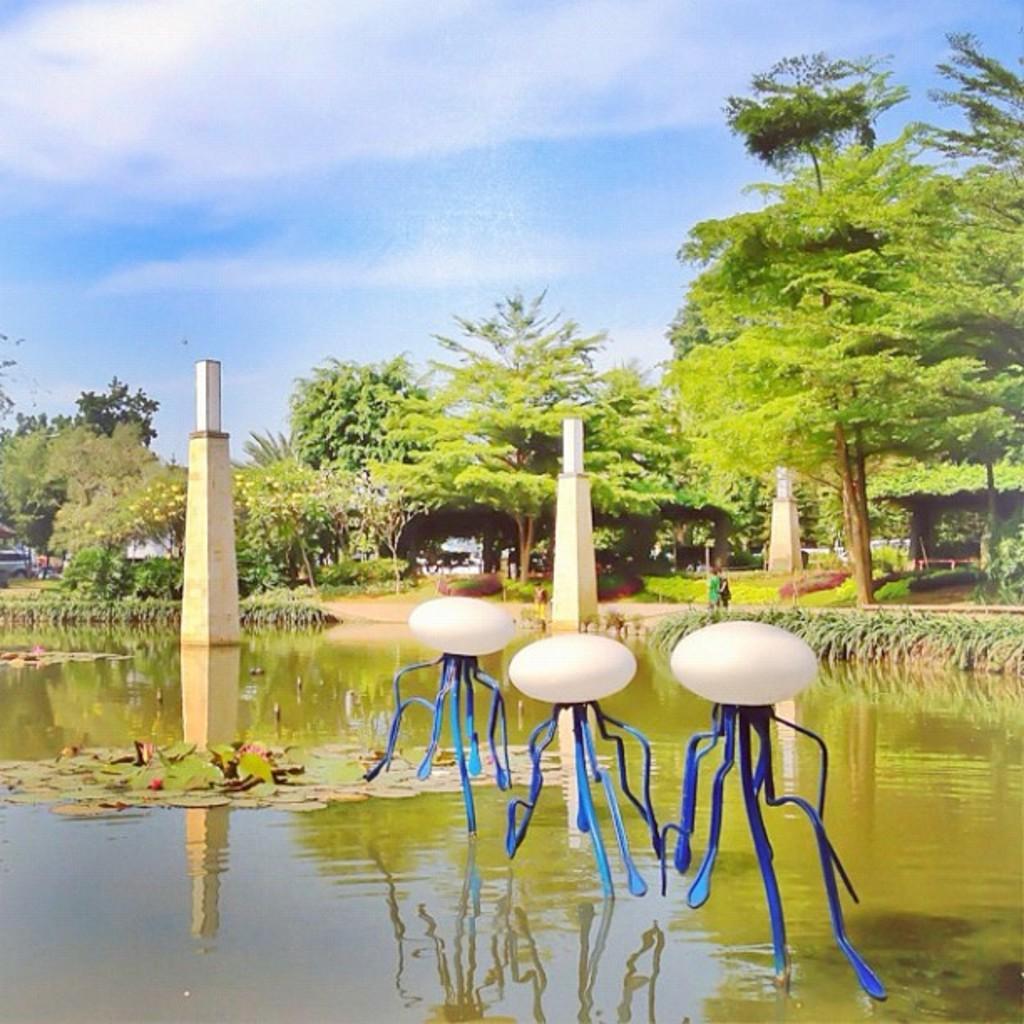Please provide a concise description of this image. In this picture I can see the lights and pillars on the water. In the background I can see many trees, plants and grass. On the right there is man who is a standing near to the water. At the top I can see the sky and clouds. On the left there is a man who is standing near to the car. 